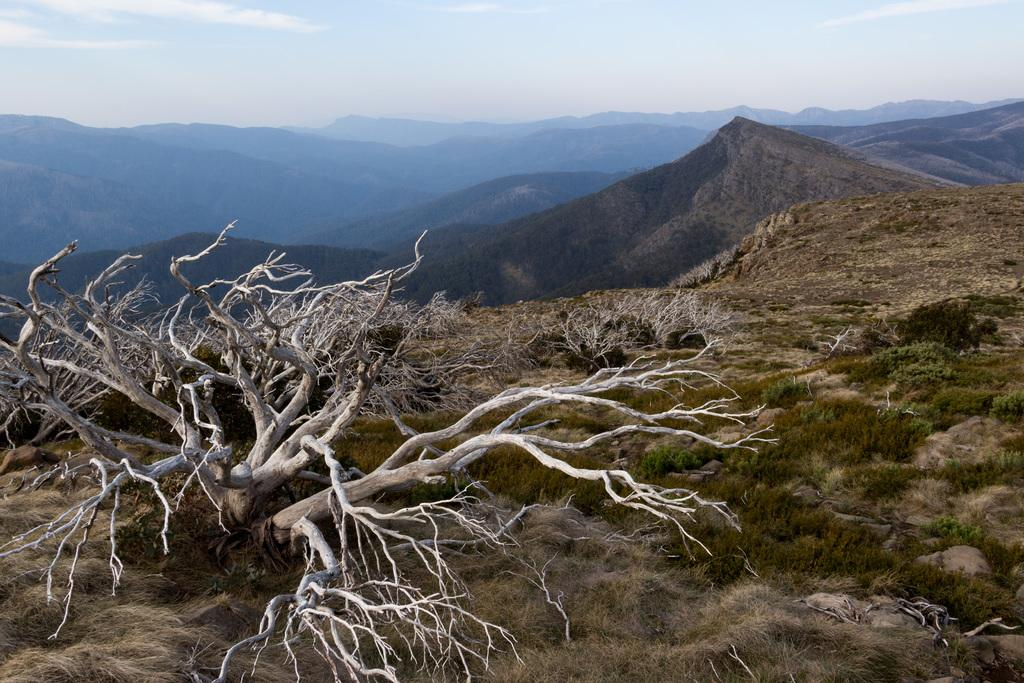What type of vegetation is on the left side of the image? There is a tree on the left side of the image. What type of ground cover is visible at the bottom of the image? There is grass at the bottom of the image. What type of landscape feature can be seen in the background of the image? There are mountains in the background of the image. What is visible in the sky in the background of the image? The sky is visible in the background of the image. How many geese are flying in harmony with the mountains in the image? There are no geese present in the image, and the concept of harmony with the mountains is not applicable to the image. 